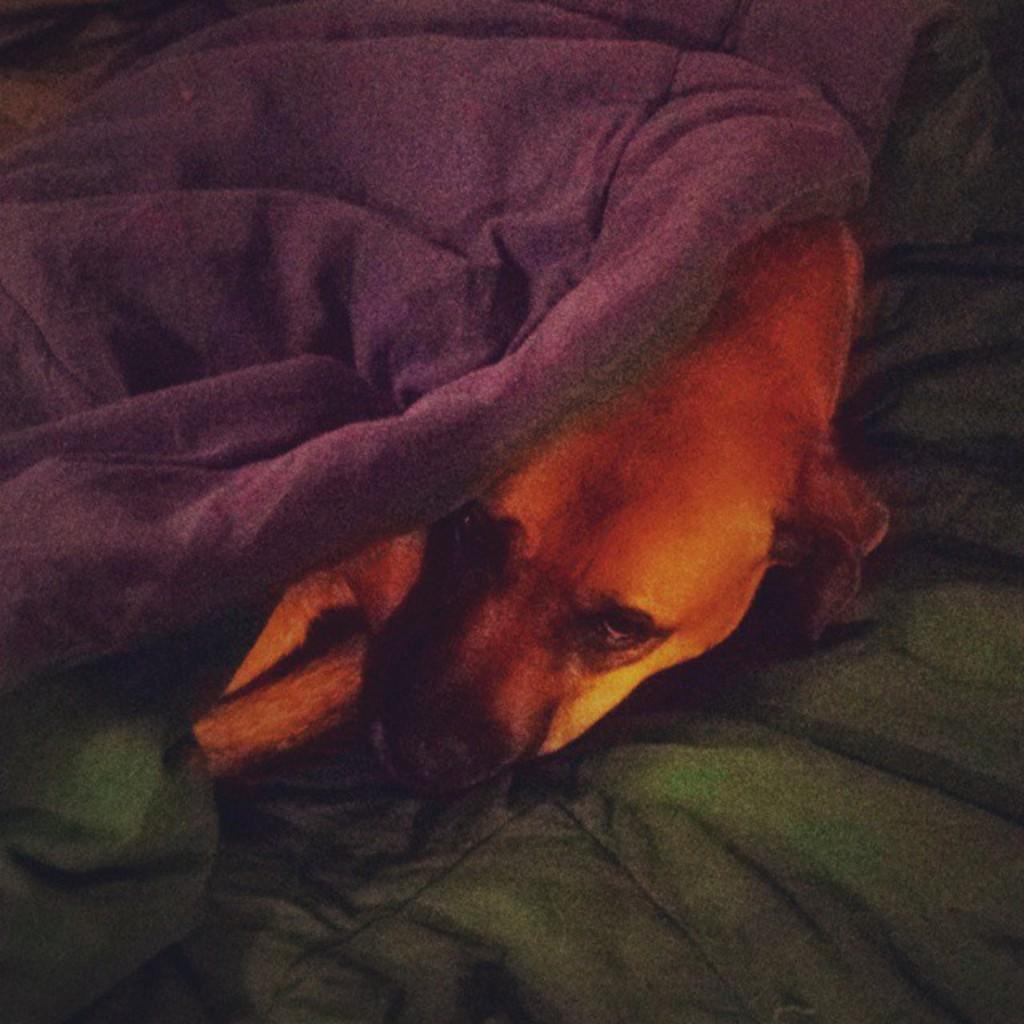Could you give a brief overview of what you see in this image? In this image I can see few clothes and between it I can see a dog. 